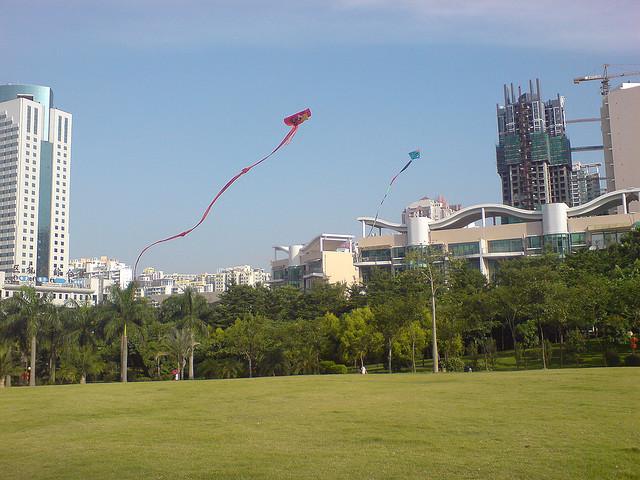Is there any construction depicted in this photo?
Answer briefly. Yes. Are these kites as high as the top of the building on the far left of the photo?
Answer briefly. No. Is this a city scene?
Short answer required. Yes. 